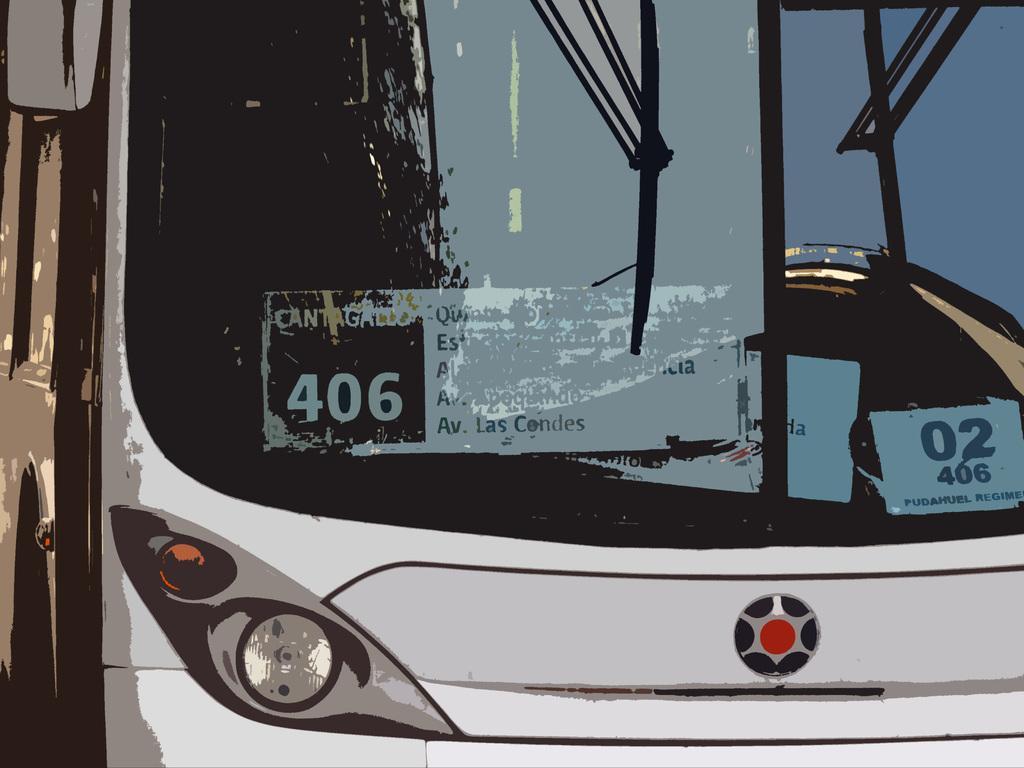In one or two sentences, can you explain what this image depicts? In the image I can see a vehicle which is white and black in color. I can see the windshield, the side mirror and the wipers. I can see few boards inside the vehicle. 